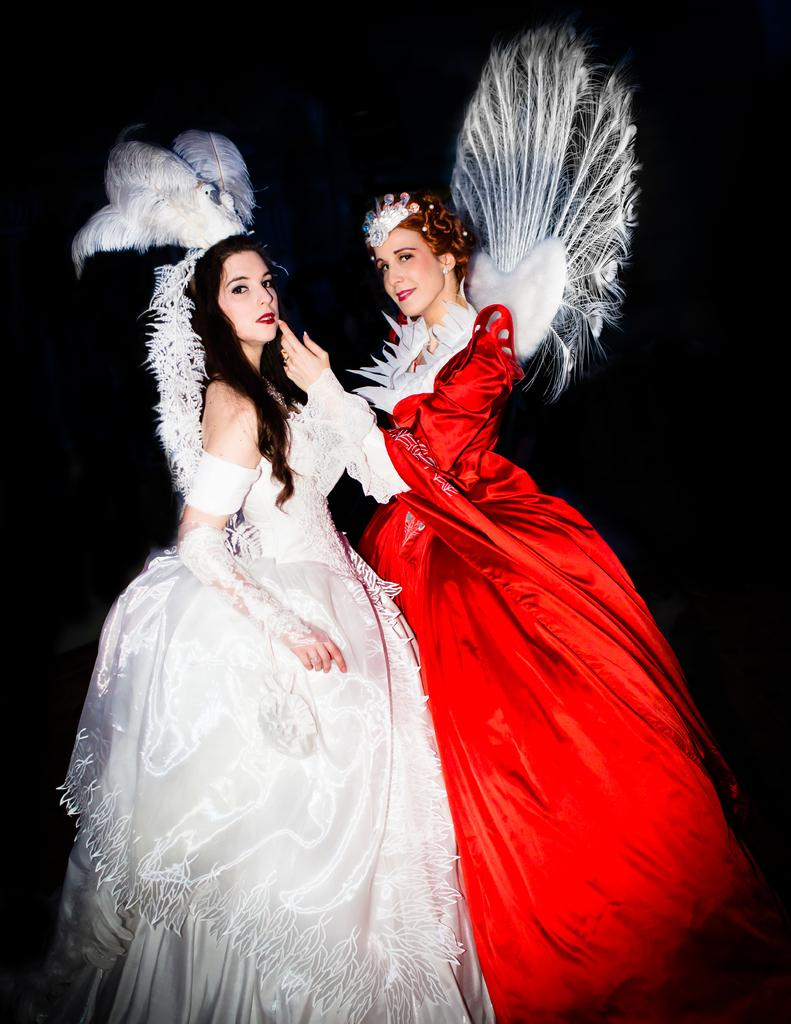How many people are in the image? There are two women in the image. What are the women doing in the image? The women are standing. What are the women wearing in the image? The women are wearing costumes. What type of hydrant can be seen in the background of the image? There is no hydrant visible in the image. What material is the copper cloth used for in the image? There is no copper cloth present in the image. 